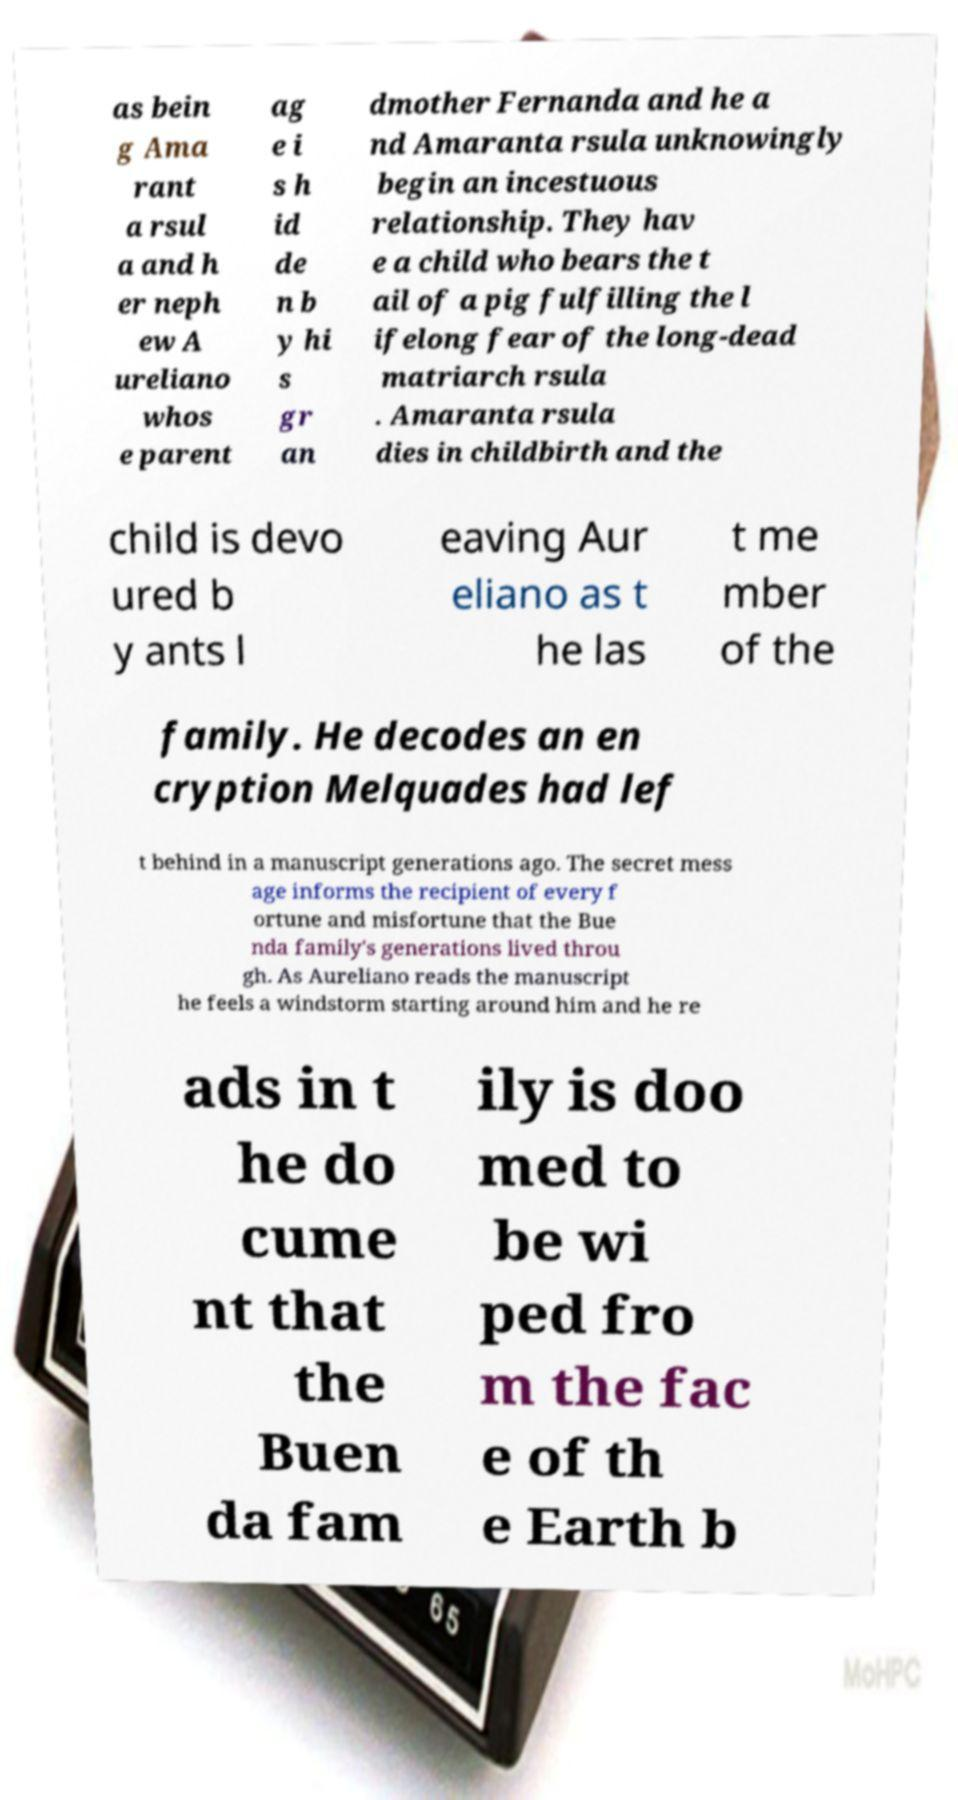For documentation purposes, I need the text within this image transcribed. Could you provide that? as bein g Ama rant a rsul a and h er neph ew A ureliano whos e parent ag e i s h id de n b y hi s gr an dmother Fernanda and he a nd Amaranta rsula unknowingly begin an incestuous relationship. They hav e a child who bears the t ail of a pig fulfilling the l ifelong fear of the long-dead matriarch rsula . Amaranta rsula dies in childbirth and the child is devo ured b y ants l eaving Aur eliano as t he las t me mber of the family. He decodes an en cryption Melquades had lef t behind in a manuscript generations ago. The secret mess age informs the recipient of every f ortune and misfortune that the Bue nda family's generations lived throu gh. As Aureliano reads the manuscript he feels a windstorm starting around him and he re ads in t he do cume nt that the Buen da fam ily is doo med to be wi ped fro m the fac e of th e Earth b 